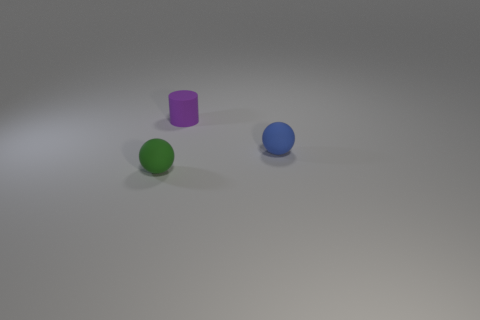Are there an equal number of spheres that are left of the small purple thing and green spheres?
Ensure brevity in your answer.  Yes. What color is the cylinder that is the same size as the green matte sphere?
Offer a terse response. Purple. How many spheres are the same color as the rubber cylinder?
Your answer should be compact. 0. What number of things are blue rubber things or tiny things right of the purple cylinder?
Ensure brevity in your answer.  1. Are there any yellow spheres that have the same material as the small cylinder?
Your answer should be compact. No. The tiny blue matte object has what shape?
Keep it short and to the point. Sphere. What shape is the rubber thing that is behind the small rubber object to the right of the purple matte thing?
Ensure brevity in your answer.  Cylinder. How many other things are the same shape as the tiny blue matte thing?
Provide a succinct answer. 1. Is there a big cyan thing?
Your answer should be compact. No. There is a tiny sphere that is left of the purple matte cylinder; how many small matte balls are right of it?
Your response must be concise. 1. 